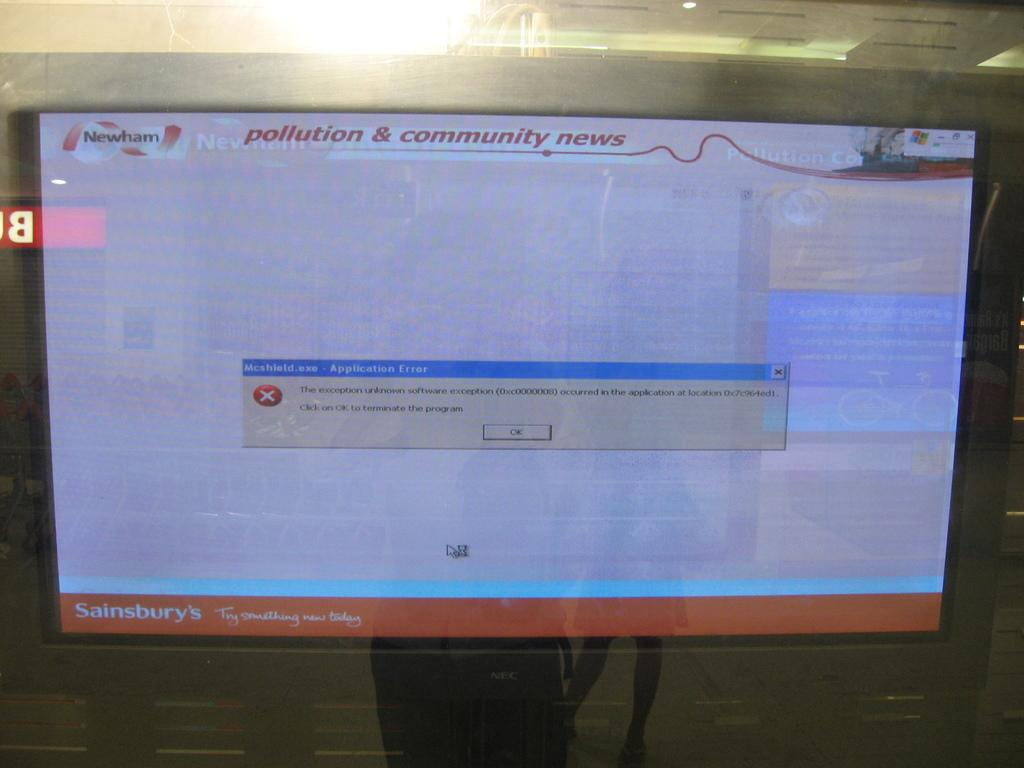<image>
Share a concise interpretation of the image provided. A screen with a Mcshield  application error box in the middle 